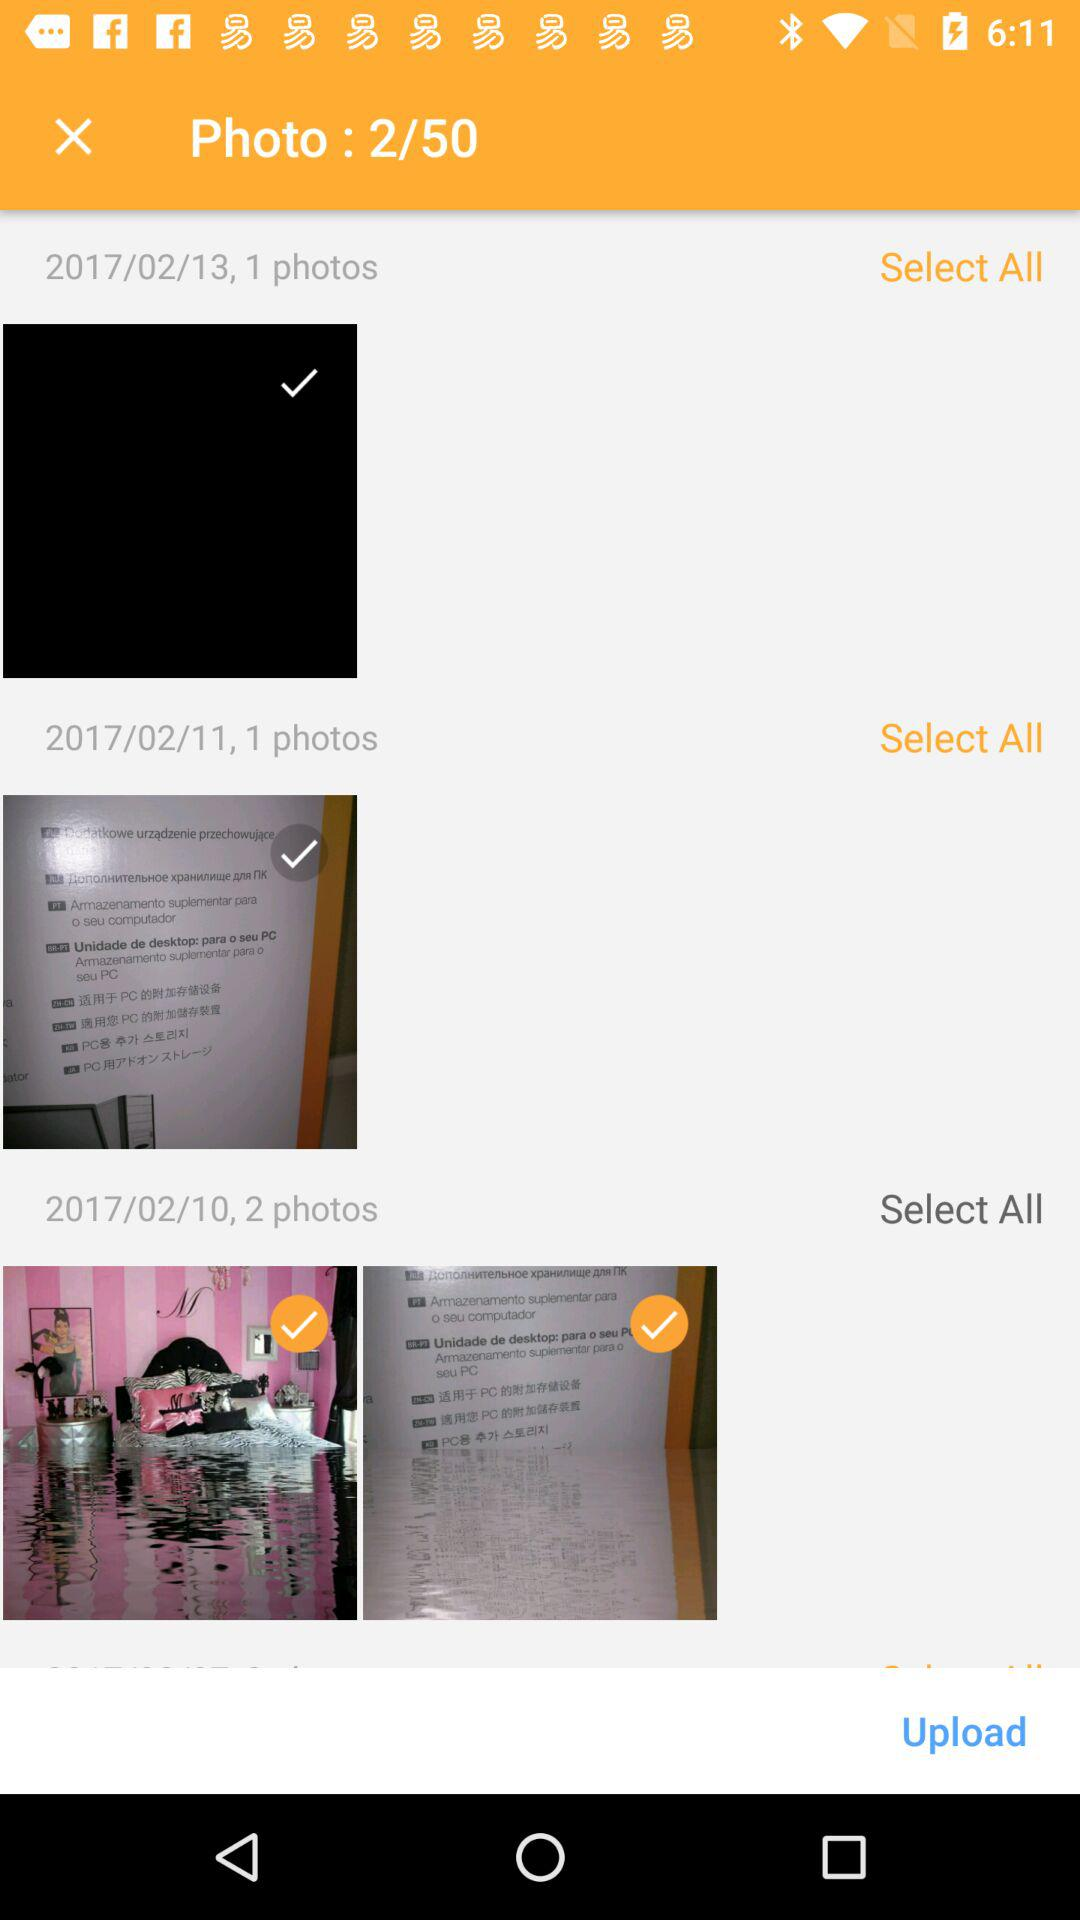How many photos in total are there? There are 50 photos in total. 